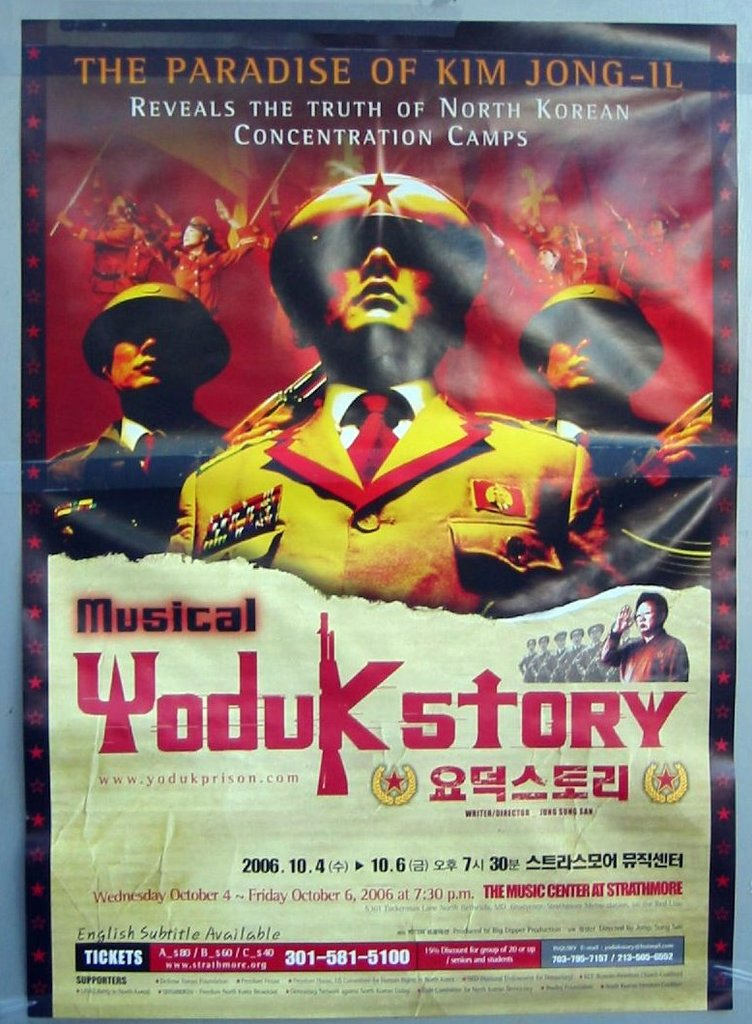What is the main theme of the 'Yoduk Story' musical as depicted in this poster? The main theme of 'Yoduk Story' as depicted in the poster is the exposure of the truth about North Korean concentration camps, reflected through dramatic and powerful imagery and references to North Korean political figures. 